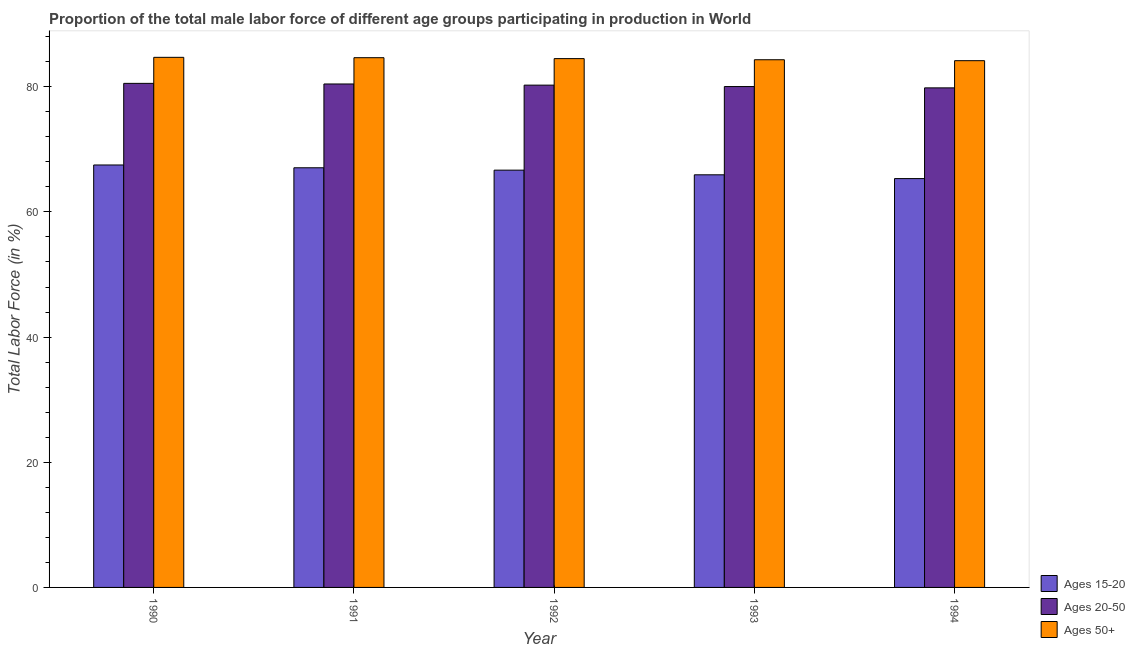How many different coloured bars are there?
Provide a succinct answer. 3. How many groups of bars are there?
Provide a short and direct response. 5. Are the number of bars on each tick of the X-axis equal?
Provide a succinct answer. Yes. What is the label of the 5th group of bars from the left?
Your answer should be very brief. 1994. In how many cases, is the number of bars for a given year not equal to the number of legend labels?
Provide a succinct answer. 0. What is the percentage of male labor force within the age group 15-20 in 1992?
Keep it short and to the point. 66.67. Across all years, what is the maximum percentage of male labor force within the age group 15-20?
Your response must be concise. 67.5. Across all years, what is the minimum percentage of male labor force above age 50?
Make the answer very short. 84.16. In which year was the percentage of male labor force within the age group 15-20 maximum?
Ensure brevity in your answer.  1990. What is the total percentage of male labor force above age 50 in the graph?
Your response must be concise. 422.31. What is the difference between the percentage of male labor force above age 50 in 1991 and that in 1994?
Your response must be concise. 0.48. What is the difference between the percentage of male labor force within the age group 15-20 in 1991 and the percentage of male labor force above age 50 in 1994?
Your response must be concise. 1.73. What is the average percentage of male labor force above age 50 per year?
Provide a short and direct response. 84.46. In how many years, is the percentage of male labor force above age 50 greater than 12 %?
Give a very brief answer. 5. What is the ratio of the percentage of male labor force above age 50 in 1990 to that in 1991?
Provide a succinct answer. 1. Is the percentage of male labor force within the age group 20-50 in 1993 less than that in 1994?
Provide a short and direct response. No. Is the difference between the percentage of male labor force within the age group 15-20 in 1991 and 1994 greater than the difference between the percentage of male labor force above age 50 in 1991 and 1994?
Give a very brief answer. No. What is the difference between the highest and the second highest percentage of male labor force above age 50?
Make the answer very short. 0.06. What is the difference between the highest and the lowest percentage of male labor force above age 50?
Make the answer very short. 0.54. Is the sum of the percentage of male labor force within the age group 20-50 in 1992 and 1994 greater than the maximum percentage of male labor force above age 50 across all years?
Ensure brevity in your answer.  Yes. What does the 3rd bar from the left in 1994 represents?
Your answer should be compact. Ages 50+. What does the 2nd bar from the right in 1993 represents?
Provide a short and direct response. Ages 20-50. Is it the case that in every year, the sum of the percentage of male labor force within the age group 15-20 and percentage of male labor force within the age group 20-50 is greater than the percentage of male labor force above age 50?
Give a very brief answer. Yes. How many years are there in the graph?
Your answer should be very brief. 5. Does the graph contain any zero values?
Your answer should be very brief. No. Where does the legend appear in the graph?
Your answer should be very brief. Bottom right. What is the title of the graph?
Offer a very short reply. Proportion of the total male labor force of different age groups participating in production in World. Does "Travel services" appear as one of the legend labels in the graph?
Offer a very short reply. No. What is the label or title of the X-axis?
Your answer should be compact. Year. What is the Total Labor Force (in %) in Ages 15-20 in 1990?
Ensure brevity in your answer.  67.5. What is the Total Labor Force (in %) in Ages 20-50 in 1990?
Provide a succinct answer. 80.54. What is the Total Labor Force (in %) in Ages 50+ in 1990?
Your response must be concise. 84.7. What is the Total Labor Force (in %) of Ages 15-20 in 1991?
Make the answer very short. 67.05. What is the Total Labor Force (in %) in Ages 20-50 in 1991?
Your answer should be compact. 80.44. What is the Total Labor Force (in %) in Ages 50+ in 1991?
Make the answer very short. 84.64. What is the Total Labor Force (in %) of Ages 15-20 in 1992?
Your answer should be compact. 66.67. What is the Total Labor Force (in %) of Ages 20-50 in 1992?
Your answer should be compact. 80.26. What is the Total Labor Force (in %) in Ages 50+ in 1992?
Make the answer very short. 84.49. What is the Total Labor Force (in %) of Ages 15-20 in 1993?
Provide a short and direct response. 65.93. What is the Total Labor Force (in %) in Ages 20-50 in 1993?
Your response must be concise. 80.03. What is the Total Labor Force (in %) of Ages 50+ in 1993?
Offer a terse response. 84.32. What is the Total Labor Force (in %) of Ages 15-20 in 1994?
Ensure brevity in your answer.  65.32. What is the Total Labor Force (in %) in Ages 20-50 in 1994?
Offer a very short reply. 79.82. What is the Total Labor Force (in %) in Ages 50+ in 1994?
Your response must be concise. 84.16. Across all years, what is the maximum Total Labor Force (in %) in Ages 15-20?
Your response must be concise. 67.5. Across all years, what is the maximum Total Labor Force (in %) of Ages 20-50?
Ensure brevity in your answer.  80.54. Across all years, what is the maximum Total Labor Force (in %) in Ages 50+?
Provide a short and direct response. 84.7. Across all years, what is the minimum Total Labor Force (in %) in Ages 15-20?
Make the answer very short. 65.32. Across all years, what is the minimum Total Labor Force (in %) of Ages 20-50?
Your answer should be compact. 79.82. Across all years, what is the minimum Total Labor Force (in %) of Ages 50+?
Provide a short and direct response. 84.16. What is the total Total Labor Force (in %) in Ages 15-20 in the graph?
Give a very brief answer. 332.48. What is the total Total Labor Force (in %) in Ages 20-50 in the graph?
Provide a succinct answer. 401.09. What is the total Total Labor Force (in %) of Ages 50+ in the graph?
Your answer should be very brief. 422.31. What is the difference between the Total Labor Force (in %) in Ages 15-20 in 1990 and that in 1991?
Make the answer very short. 0.45. What is the difference between the Total Labor Force (in %) in Ages 20-50 in 1990 and that in 1991?
Your answer should be compact. 0.1. What is the difference between the Total Labor Force (in %) in Ages 50+ in 1990 and that in 1991?
Provide a succinct answer. 0.06. What is the difference between the Total Labor Force (in %) in Ages 15-20 in 1990 and that in 1992?
Your answer should be compact. 0.83. What is the difference between the Total Labor Force (in %) in Ages 20-50 in 1990 and that in 1992?
Offer a terse response. 0.28. What is the difference between the Total Labor Force (in %) of Ages 50+ in 1990 and that in 1992?
Make the answer very short. 0.2. What is the difference between the Total Labor Force (in %) of Ages 15-20 in 1990 and that in 1993?
Keep it short and to the point. 1.57. What is the difference between the Total Labor Force (in %) of Ages 20-50 in 1990 and that in 1993?
Keep it short and to the point. 0.51. What is the difference between the Total Labor Force (in %) of Ages 50+ in 1990 and that in 1993?
Your response must be concise. 0.38. What is the difference between the Total Labor Force (in %) of Ages 15-20 in 1990 and that in 1994?
Provide a succinct answer. 2.17. What is the difference between the Total Labor Force (in %) in Ages 20-50 in 1990 and that in 1994?
Keep it short and to the point. 0.72. What is the difference between the Total Labor Force (in %) in Ages 50+ in 1990 and that in 1994?
Offer a terse response. 0.54. What is the difference between the Total Labor Force (in %) of Ages 15-20 in 1991 and that in 1992?
Your answer should be very brief. 0.38. What is the difference between the Total Labor Force (in %) of Ages 20-50 in 1991 and that in 1992?
Offer a very short reply. 0.18. What is the difference between the Total Labor Force (in %) in Ages 50+ in 1991 and that in 1992?
Your answer should be very brief. 0.15. What is the difference between the Total Labor Force (in %) of Ages 15-20 in 1991 and that in 1993?
Provide a short and direct response. 1.12. What is the difference between the Total Labor Force (in %) in Ages 20-50 in 1991 and that in 1993?
Your response must be concise. 0.41. What is the difference between the Total Labor Force (in %) in Ages 50+ in 1991 and that in 1993?
Offer a very short reply. 0.33. What is the difference between the Total Labor Force (in %) in Ages 15-20 in 1991 and that in 1994?
Provide a succinct answer. 1.73. What is the difference between the Total Labor Force (in %) in Ages 20-50 in 1991 and that in 1994?
Offer a terse response. 0.62. What is the difference between the Total Labor Force (in %) of Ages 50+ in 1991 and that in 1994?
Give a very brief answer. 0.48. What is the difference between the Total Labor Force (in %) of Ages 15-20 in 1992 and that in 1993?
Provide a succinct answer. 0.74. What is the difference between the Total Labor Force (in %) of Ages 20-50 in 1992 and that in 1993?
Your response must be concise. 0.23. What is the difference between the Total Labor Force (in %) of Ages 50+ in 1992 and that in 1993?
Your response must be concise. 0.18. What is the difference between the Total Labor Force (in %) of Ages 15-20 in 1992 and that in 1994?
Offer a terse response. 1.35. What is the difference between the Total Labor Force (in %) in Ages 20-50 in 1992 and that in 1994?
Give a very brief answer. 0.44. What is the difference between the Total Labor Force (in %) in Ages 50+ in 1992 and that in 1994?
Your answer should be compact. 0.33. What is the difference between the Total Labor Force (in %) of Ages 15-20 in 1993 and that in 1994?
Your response must be concise. 0.61. What is the difference between the Total Labor Force (in %) of Ages 20-50 in 1993 and that in 1994?
Your answer should be very brief. 0.21. What is the difference between the Total Labor Force (in %) of Ages 50+ in 1993 and that in 1994?
Ensure brevity in your answer.  0.15. What is the difference between the Total Labor Force (in %) of Ages 15-20 in 1990 and the Total Labor Force (in %) of Ages 20-50 in 1991?
Ensure brevity in your answer.  -12.94. What is the difference between the Total Labor Force (in %) of Ages 15-20 in 1990 and the Total Labor Force (in %) of Ages 50+ in 1991?
Provide a short and direct response. -17.14. What is the difference between the Total Labor Force (in %) in Ages 20-50 in 1990 and the Total Labor Force (in %) in Ages 50+ in 1991?
Ensure brevity in your answer.  -4.1. What is the difference between the Total Labor Force (in %) in Ages 15-20 in 1990 and the Total Labor Force (in %) in Ages 20-50 in 1992?
Offer a very short reply. -12.76. What is the difference between the Total Labor Force (in %) in Ages 15-20 in 1990 and the Total Labor Force (in %) in Ages 50+ in 1992?
Provide a short and direct response. -17. What is the difference between the Total Labor Force (in %) of Ages 20-50 in 1990 and the Total Labor Force (in %) of Ages 50+ in 1992?
Keep it short and to the point. -3.96. What is the difference between the Total Labor Force (in %) in Ages 15-20 in 1990 and the Total Labor Force (in %) in Ages 20-50 in 1993?
Ensure brevity in your answer.  -12.53. What is the difference between the Total Labor Force (in %) of Ages 15-20 in 1990 and the Total Labor Force (in %) of Ages 50+ in 1993?
Make the answer very short. -16.82. What is the difference between the Total Labor Force (in %) of Ages 20-50 in 1990 and the Total Labor Force (in %) of Ages 50+ in 1993?
Provide a succinct answer. -3.78. What is the difference between the Total Labor Force (in %) in Ages 15-20 in 1990 and the Total Labor Force (in %) in Ages 20-50 in 1994?
Offer a terse response. -12.32. What is the difference between the Total Labor Force (in %) of Ages 15-20 in 1990 and the Total Labor Force (in %) of Ages 50+ in 1994?
Keep it short and to the point. -16.66. What is the difference between the Total Labor Force (in %) of Ages 20-50 in 1990 and the Total Labor Force (in %) of Ages 50+ in 1994?
Provide a short and direct response. -3.63. What is the difference between the Total Labor Force (in %) in Ages 15-20 in 1991 and the Total Labor Force (in %) in Ages 20-50 in 1992?
Provide a succinct answer. -13.21. What is the difference between the Total Labor Force (in %) of Ages 15-20 in 1991 and the Total Labor Force (in %) of Ages 50+ in 1992?
Make the answer very short. -17.44. What is the difference between the Total Labor Force (in %) of Ages 20-50 in 1991 and the Total Labor Force (in %) of Ages 50+ in 1992?
Offer a terse response. -4.05. What is the difference between the Total Labor Force (in %) in Ages 15-20 in 1991 and the Total Labor Force (in %) in Ages 20-50 in 1993?
Give a very brief answer. -12.98. What is the difference between the Total Labor Force (in %) of Ages 15-20 in 1991 and the Total Labor Force (in %) of Ages 50+ in 1993?
Offer a very short reply. -17.26. What is the difference between the Total Labor Force (in %) of Ages 20-50 in 1991 and the Total Labor Force (in %) of Ages 50+ in 1993?
Offer a terse response. -3.87. What is the difference between the Total Labor Force (in %) of Ages 15-20 in 1991 and the Total Labor Force (in %) of Ages 20-50 in 1994?
Offer a terse response. -12.77. What is the difference between the Total Labor Force (in %) of Ages 15-20 in 1991 and the Total Labor Force (in %) of Ages 50+ in 1994?
Your answer should be very brief. -17.11. What is the difference between the Total Labor Force (in %) in Ages 20-50 in 1991 and the Total Labor Force (in %) in Ages 50+ in 1994?
Your answer should be compact. -3.72. What is the difference between the Total Labor Force (in %) in Ages 15-20 in 1992 and the Total Labor Force (in %) in Ages 20-50 in 1993?
Keep it short and to the point. -13.36. What is the difference between the Total Labor Force (in %) of Ages 15-20 in 1992 and the Total Labor Force (in %) of Ages 50+ in 1993?
Provide a short and direct response. -17.64. What is the difference between the Total Labor Force (in %) in Ages 20-50 in 1992 and the Total Labor Force (in %) in Ages 50+ in 1993?
Provide a succinct answer. -4.06. What is the difference between the Total Labor Force (in %) of Ages 15-20 in 1992 and the Total Labor Force (in %) of Ages 20-50 in 1994?
Keep it short and to the point. -13.15. What is the difference between the Total Labor Force (in %) in Ages 15-20 in 1992 and the Total Labor Force (in %) in Ages 50+ in 1994?
Make the answer very short. -17.49. What is the difference between the Total Labor Force (in %) in Ages 20-50 in 1992 and the Total Labor Force (in %) in Ages 50+ in 1994?
Keep it short and to the point. -3.91. What is the difference between the Total Labor Force (in %) in Ages 15-20 in 1993 and the Total Labor Force (in %) in Ages 20-50 in 1994?
Your answer should be very brief. -13.89. What is the difference between the Total Labor Force (in %) in Ages 15-20 in 1993 and the Total Labor Force (in %) in Ages 50+ in 1994?
Your answer should be compact. -18.23. What is the difference between the Total Labor Force (in %) of Ages 20-50 in 1993 and the Total Labor Force (in %) of Ages 50+ in 1994?
Ensure brevity in your answer.  -4.13. What is the average Total Labor Force (in %) in Ages 15-20 per year?
Ensure brevity in your answer.  66.5. What is the average Total Labor Force (in %) in Ages 20-50 per year?
Provide a short and direct response. 80.22. What is the average Total Labor Force (in %) in Ages 50+ per year?
Make the answer very short. 84.46. In the year 1990, what is the difference between the Total Labor Force (in %) in Ages 15-20 and Total Labor Force (in %) in Ages 20-50?
Your answer should be very brief. -13.04. In the year 1990, what is the difference between the Total Labor Force (in %) in Ages 15-20 and Total Labor Force (in %) in Ages 50+?
Offer a terse response. -17.2. In the year 1990, what is the difference between the Total Labor Force (in %) of Ages 20-50 and Total Labor Force (in %) of Ages 50+?
Ensure brevity in your answer.  -4.16. In the year 1991, what is the difference between the Total Labor Force (in %) in Ages 15-20 and Total Labor Force (in %) in Ages 20-50?
Offer a very short reply. -13.39. In the year 1991, what is the difference between the Total Labor Force (in %) in Ages 15-20 and Total Labor Force (in %) in Ages 50+?
Ensure brevity in your answer.  -17.59. In the year 1991, what is the difference between the Total Labor Force (in %) in Ages 20-50 and Total Labor Force (in %) in Ages 50+?
Your answer should be very brief. -4.2. In the year 1992, what is the difference between the Total Labor Force (in %) of Ages 15-20 and Total Labor Force (in %) of Ages 20-50?
Provide a succinct answer. -13.58. In the year 1992, what is the difference between the Total Labor Force (in %) of Ages 15-20 and Total Labor Force (in %) of Ages 50+?
Offer a terse response. -17.82. In the year 1992, what is the difference between the Total Labor Force (in %) in Ages 20-50 and Total Labor Force (in %) in Ages 50+?
Give a very brief answer. -4.24. In the year 1993, what is the difference between the Total Labor Force (in %) of Ages 15-20 and Total Labor Force (in %) of Ages 20-50?
Provide a succinct answer. -14.1. In the year 1993, what is the difference between the Total Labor Force (in %) in Ages 15-20 and Total Labor Force (in %) in Ages 50+?
Offer a terse response. -18.39. In the year 1993, what is the difference between the Total Labor Force (in %) in Ages 20-50 and Total Labor Force (in %) in Ages 50+?
Your response must be concise. -4.28. In the year 1994, what is the difference between the Total Labor Force (in %) of Ages 15-20 and Total Labor Force (in %) of Ages 20-50?
Your answer should be compact. -14.5. In the year 1994, what is the difference between the Total Labor Force (in %) of Ages 15-20 and Total Labor Force (in %) of Ages 50+?
Give a very brief answer. -18.84. In the year 1994, what is the difference between the Total Labor Force (in %) in Ages 20-50 and Total Labor Force (in %) in Ages 50+?
Your response must be concise. -4.34. What is the ratio of the Total Labor Force (in %) of Ages 20-50 in 1990 to that in 1991?
Your response must be concise. 1. What is the ratio of the Total Labor Force (in %) in Ages 50+ in 1990 to that in 1991?
Your answer should be compact. 1. What is the ratio of the Total Labor Force (in %) of Ages 15-20 in 1990 to that in 1992?
Provide a short and direct response. 1.01. What is the ratio of the Total Labor Force (in %) of Ages 15-20 in 1990 to that in 1993?
Offer a very short reply. 1.02. What is the ratio of the Total Labor Force (in %) in Ages 20-50 in 1990 to that in 1993?
Keep it short and to the point. 1.01. What is the ratio of the Total Labor Force (in %) of Ages 20-50 in 1990 to that in 1994?
Your response must be concise. 1.01. What is the ratio of the Total Labor Force (in %) in Ages 50+ in 1990 to that in 1994?
Keep it short and to the point. 1.01. What is the ratio of the Total Labor Force (in %) of Ages 15-20 in 1991 to that in 1992?
Ensure brevity in your answer.  1.01. What is the ratio of the Total Labor Force (in %) of Ages 50+ in 1991 to that in 1992?
Offer a very short reply. 1. What is the ratio of the Total Labor Force (in %) in Ages 20-50 in 1991 to that in 1993?
Offer a terse response. 1.01. What is the ratio of the Total Labor Force (in %) in Ages 15-20 in 1991 to that in 1994?
Make the answer very short. 1.03. What is the ratio of the Total Labor Force (in %) of Ages 50+ in 1991 to that in 1994?
Offer a very short reply. 1.01. What is the ratio of the Total Labor Force (in %) of Ages 15-20 in 1992 to that in 1993?
Offer a very short reply. 1.01. What is the ratio of the Total Labor Force (in %) in Ages 50+ in 1992 to that in 1993?
Provide a short and direct response. 1. What is the ratio of the Total Labor Force (in %) of Ages 15-20 in 1992 to that in 1994?
Give a very brief answer. 1.02. What is the ratio of the Total Labor Force (in %) in Ages 50+ in 1992 to that in 1994?
Ensure brevity in your answer.  1. What is the ratio of the Total Labor Force (in %) in Ages 15-20 in 1993 to that in 1994?
Offer a very short reply. 1.01. What is the difference between the highest and the second highest Total Labor Force (in %) of Ages 15-20?
Ensure brevity in your answer.  0.45. What is the difference between the highest and the second highest Total Labor Force (in %) of Ages 20-50?
Offer a very short reply. 0.1. What is the difference between the highest and the second highest Total Labor Force (in %) of Ages 50+?
Make the answer very short. 0.06. What is the difference between the highest and the lowest Total Labor Force (in %) in Ages 15-20?
Provide a succinct answer. 2.17. What is the difference between the highest and the lowest Total Labor Force (in %) of Ages 20-50?
Your answer should be very brief. 0.72. What is the difference between the highest and the lowest Total Labor Force (in %) of Ages 50+?
Keep it short and to the point. 0.54. 